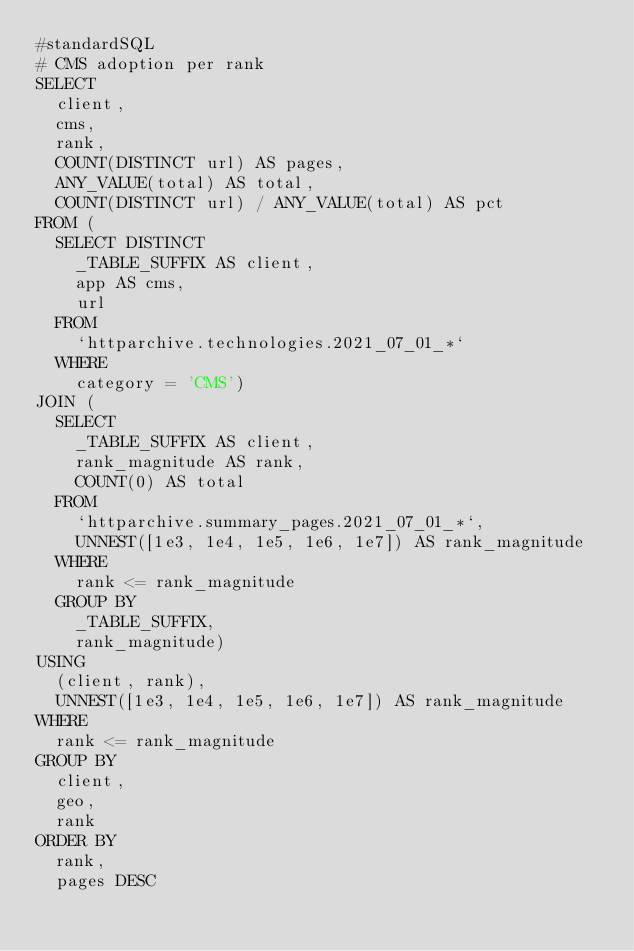<code> <loc_0><loc_0><loc_500><loc_500><_SQL_>#standardSQL
# CMS adoption per rank
SELECT
  client,
  cms,
  rank,
  COUNT(DISTINCT url) AS pages,
  ANY_VALUE(total) AS total,
  COUNT(DISTINCT url) / ANY_VALUE(total) AS pct
FROM (
  SELECT DISTINCT
    _TABLE_SUFFIX AS client,
    app AS cms,
    url
  FROM
    `httparchive.technologies.2021_07_01_*`
  WHERE
    category = 'CMS')
JOIN (
  SELECT
    _TABLE_SUFFIX AS client,
    rank_magnitude AS rank,
    COUNT(0) AS total
  FROM
    `httparchive.summary_pages.2021_07_01_*`,
    UNNEST([1e3, 1e4, 1e5, 1e6, 1e7]) AS rank_magnitude
  WHERE
    rank <= rank_magnitude
  GROUP BY
    _TABLE_SUFFIX,
    rank_magnitude)
USING
  (client, rank),
  UNNEST([1e3, 1e4, 1e5, 1e6, 1e7]) AS rank_magnitude
WHERE
  rank <= rank_magnitude
GROUP BY
  client,
  geo,
  rank
ORDER BY
  rank,
  pages DESC
</code> 